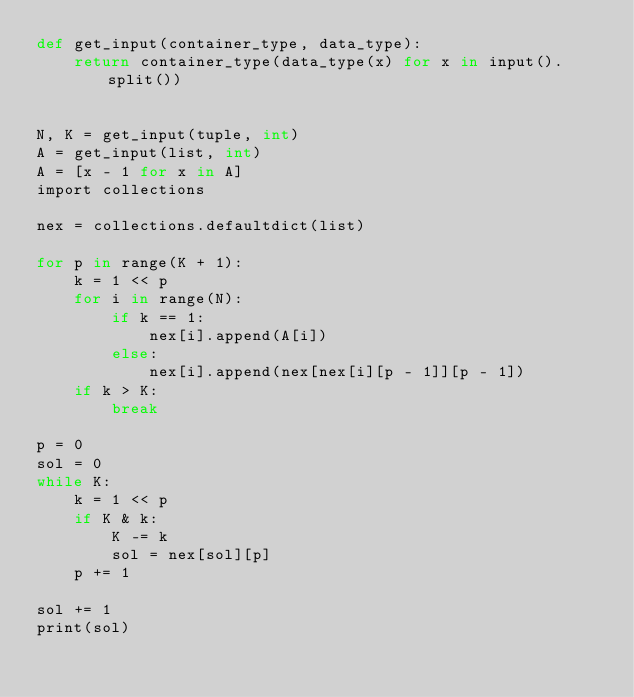<code> <loc_0><loc_0><loc_500><loc_500><_Cython_>def get_input(container_type, data_type):
    return container_type(data_type(x) for x in input().split())


N, K = get_input(tuple, int)
A = get_input(list, int)
A = [x - 1 for x in A]
import collections

nex = collections.defaultdict(list)

for p in range(K + 1):
    k = 1 << p
    for i in range(N):
        if k == 1:
            nex[i].append(A[i])
        else:
            nex[i].append(nex[nex[i][p - 1]][p - 1])
    if k > K:
        break

p = 0
sol = 0
while K:
    k = 1 << p
    if K & k:
        K -= k
        sol = nex[sol][p]
    p += 1

sol += 1
print(sol)
</code> 